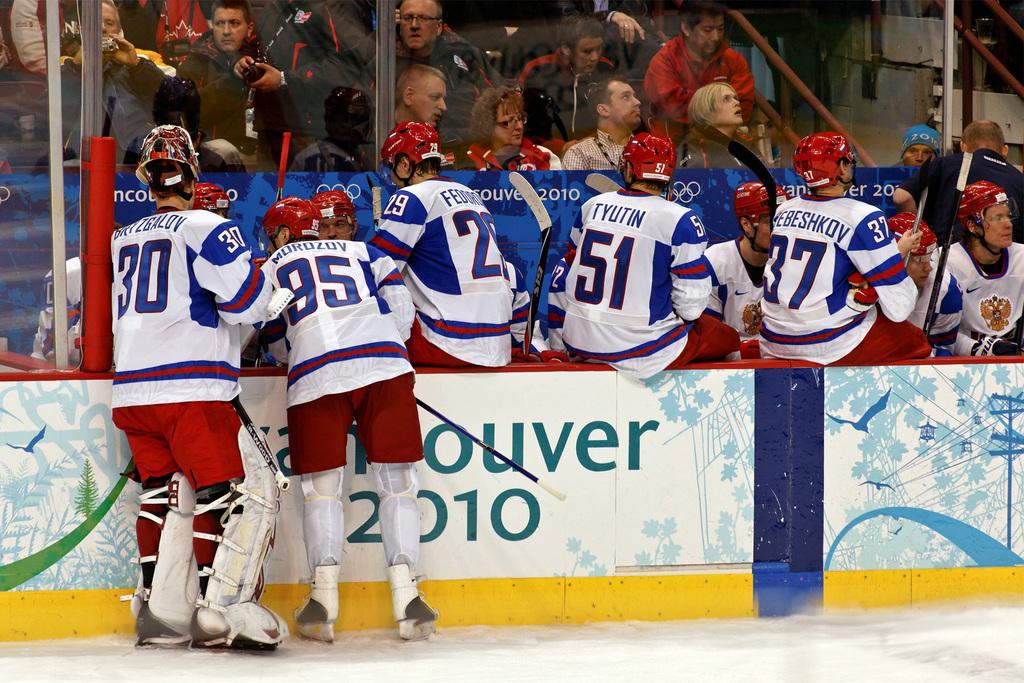What is the name of number 51's jersey?
Ensure brevity in your answer.  Tyutin. What year is this?
Keep it short and to the point. 2010. 